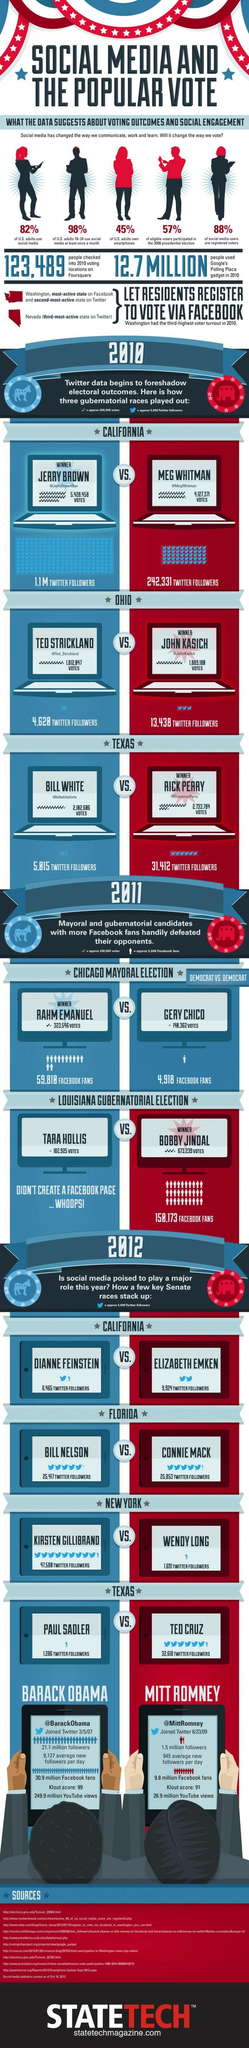List a handful of essential elements in this visual. The Ohio winner has 13,438 Twitter followers. The Twitter handle of the winner in California is @JerryBrownGov. Barack Obama has a higher Klout score than Mitt Romney, as declared. Connie Mack had more Twitter followers in Florida than any other person. Of the individuals listed, TARA HOLLIS does not have a Facebook page. 